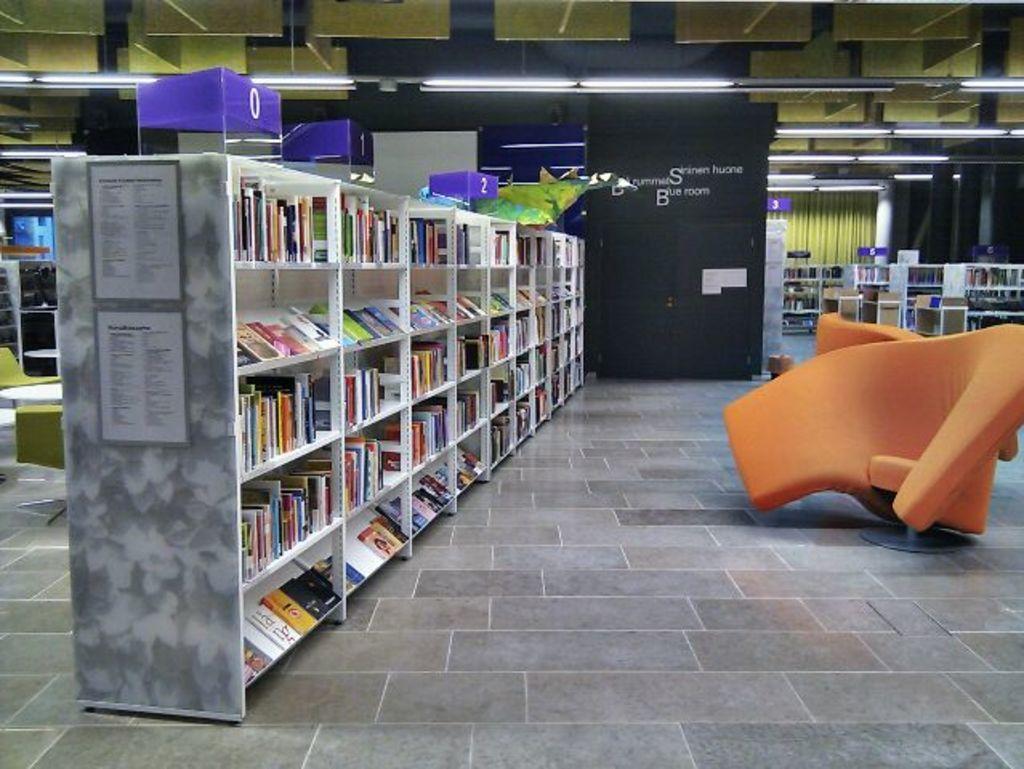Could you give a brief overview of what you see in this image? This picture shows an inner view of a hall. We see chairs and book shelves with books and we see lights and few chairs and tables. 